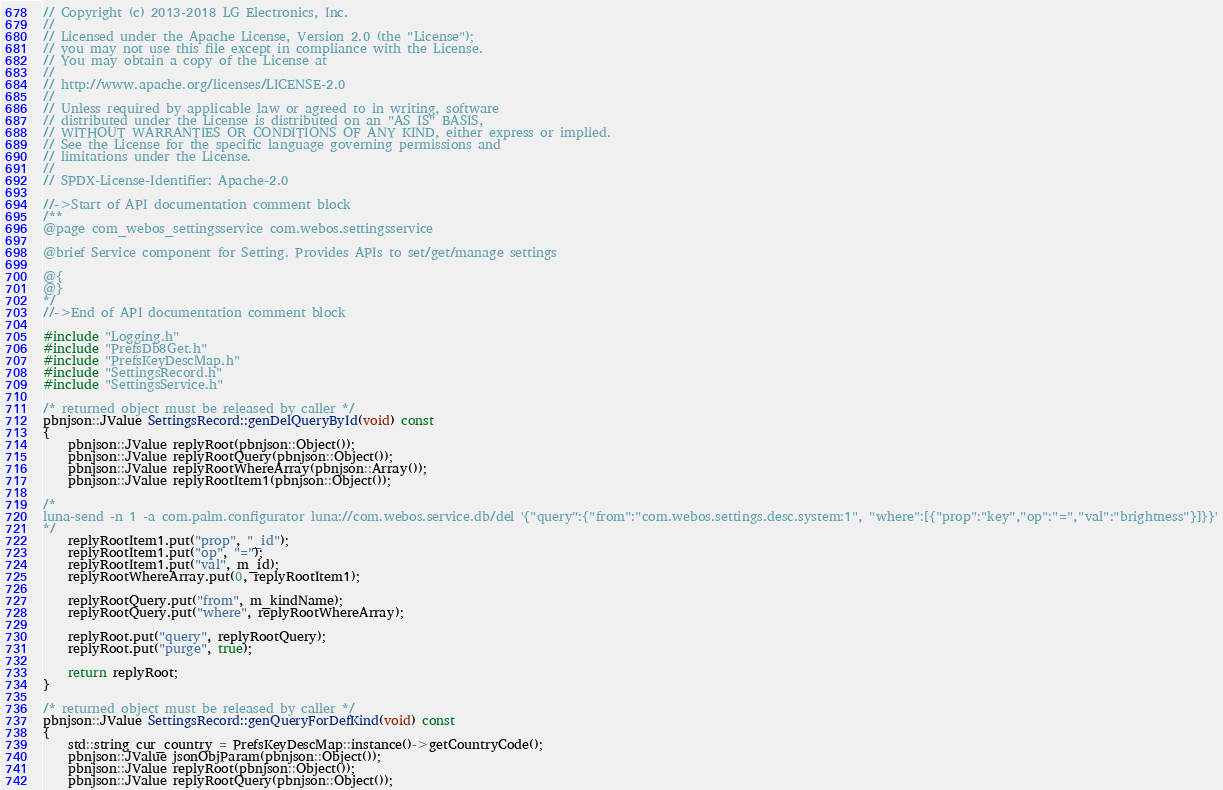Convert code to text. <code><loc_0><loc_0><loc_500><loc_500><_C++_>// Copyright (c) 2013-2018 LG Electronics, Inc.
//
// Licensed under the Apache License, Version 2.0 (the "License");
// you may not use this file except in compliance with the License.
// You may obtain a copy of the License at
//
// http://www.apache.org/licenses/LICENSE-2.0
//
// Unless required by applicable law or agreed to in writing, software
// distributed under the License is distributed on an "AS IS" BASIS,
// WITHOUT WARRANTIES OR CONDITIONS OF ANY KIND, either express or implied.
// See the License for the specific language governing permissions and
// limitations under the License.
//
// SPDX-License-Identifier: Apache-2.0

//->Start of API documentation comment block
/**
@page com_webos_settingsservice com.webos.settingsservice

@brief Service component for Setting. Provides APIs to set/get/manage settings

@{
@}
*/
//->End of API documentation comment block

#include "Logging.h"
#include "PrefsDb8Get.h"
#include "PrefsKeyDescMap.h"
#include "SettingsRecord.h"
#include "SettingsService.h"

/* returned object must be released by caller */
pbnjson::JValue SettingsRecord::genDelQueryById(void) const
{
    pbnjson::JValue replyRoot(pbnjson::Object());
    pbnjson::JValue replyRootQuery(pbnjson::Object());
    pbnjson::JValue replyRootWhereArray(pbnjson::Array());
    pbnjson::JValue replyRootItem1(pbnjson::Object());

/*
luna-send -n 1 -a com.palm.configurator luna://com.webos.service.db/del '{"query":{"from":"com.webos.settings.desc.system:1", "where":[{"prop":"key","op":"=","val":"brightness"}]}}'
*/
    replyRootItem1.put("prop", "_id");
    replyRootItem1.put("op", "=");
    replyRootItem1.put("val", m_id);
    replyRootWhereArray.put(0, replyRootItem1);

    replyRootQuery.put("from", m_kindName);
    replyRootQuery.put("where", replyRootWhereArray);

    replyRoot.put("query", replyRootQuery);
    replyRoot.put("purge", true);

    return replyRoot;
}

/* returned object must be released by caller */
pbnjson::JValue SettingsRecord::genQueryForDefKind(void) const
{
    std::string cur_country = PrefsKeyDescMap::instance()->getCountryCode();
    pbnjson::JValue jsonObjParam(pbnjson::Object());
    pbnjson::JValue replyRoot(pbnjson::Object());
    pbnjson::JValue replyRootQuery(pbnjson::Object());</code> 